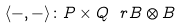Convert formula to latex. <formula><loc_0><loc_0><loc_500><loc_500>\langle - , - \rangle \colon P \times Q \ r B \otimes B</formula> 